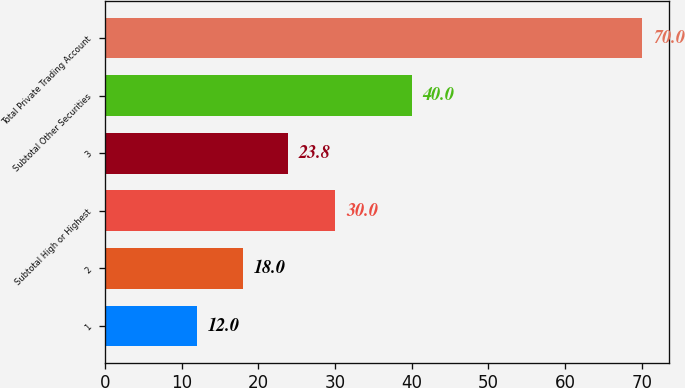Convert chart to OTSL. <chart><loc_0><loc_0><loc_500><loc_500><bar_chart><fcel>1<fcel>2<fcel>Subtotal High or Highest<fcel>3<fcel>Subtotal Other Securities<fcel>Total Private Trading Account<nl><fcel>12<fcel>18<fcel>30<fcel>23.8<fcel>40<fcel>70<nl></chart> 